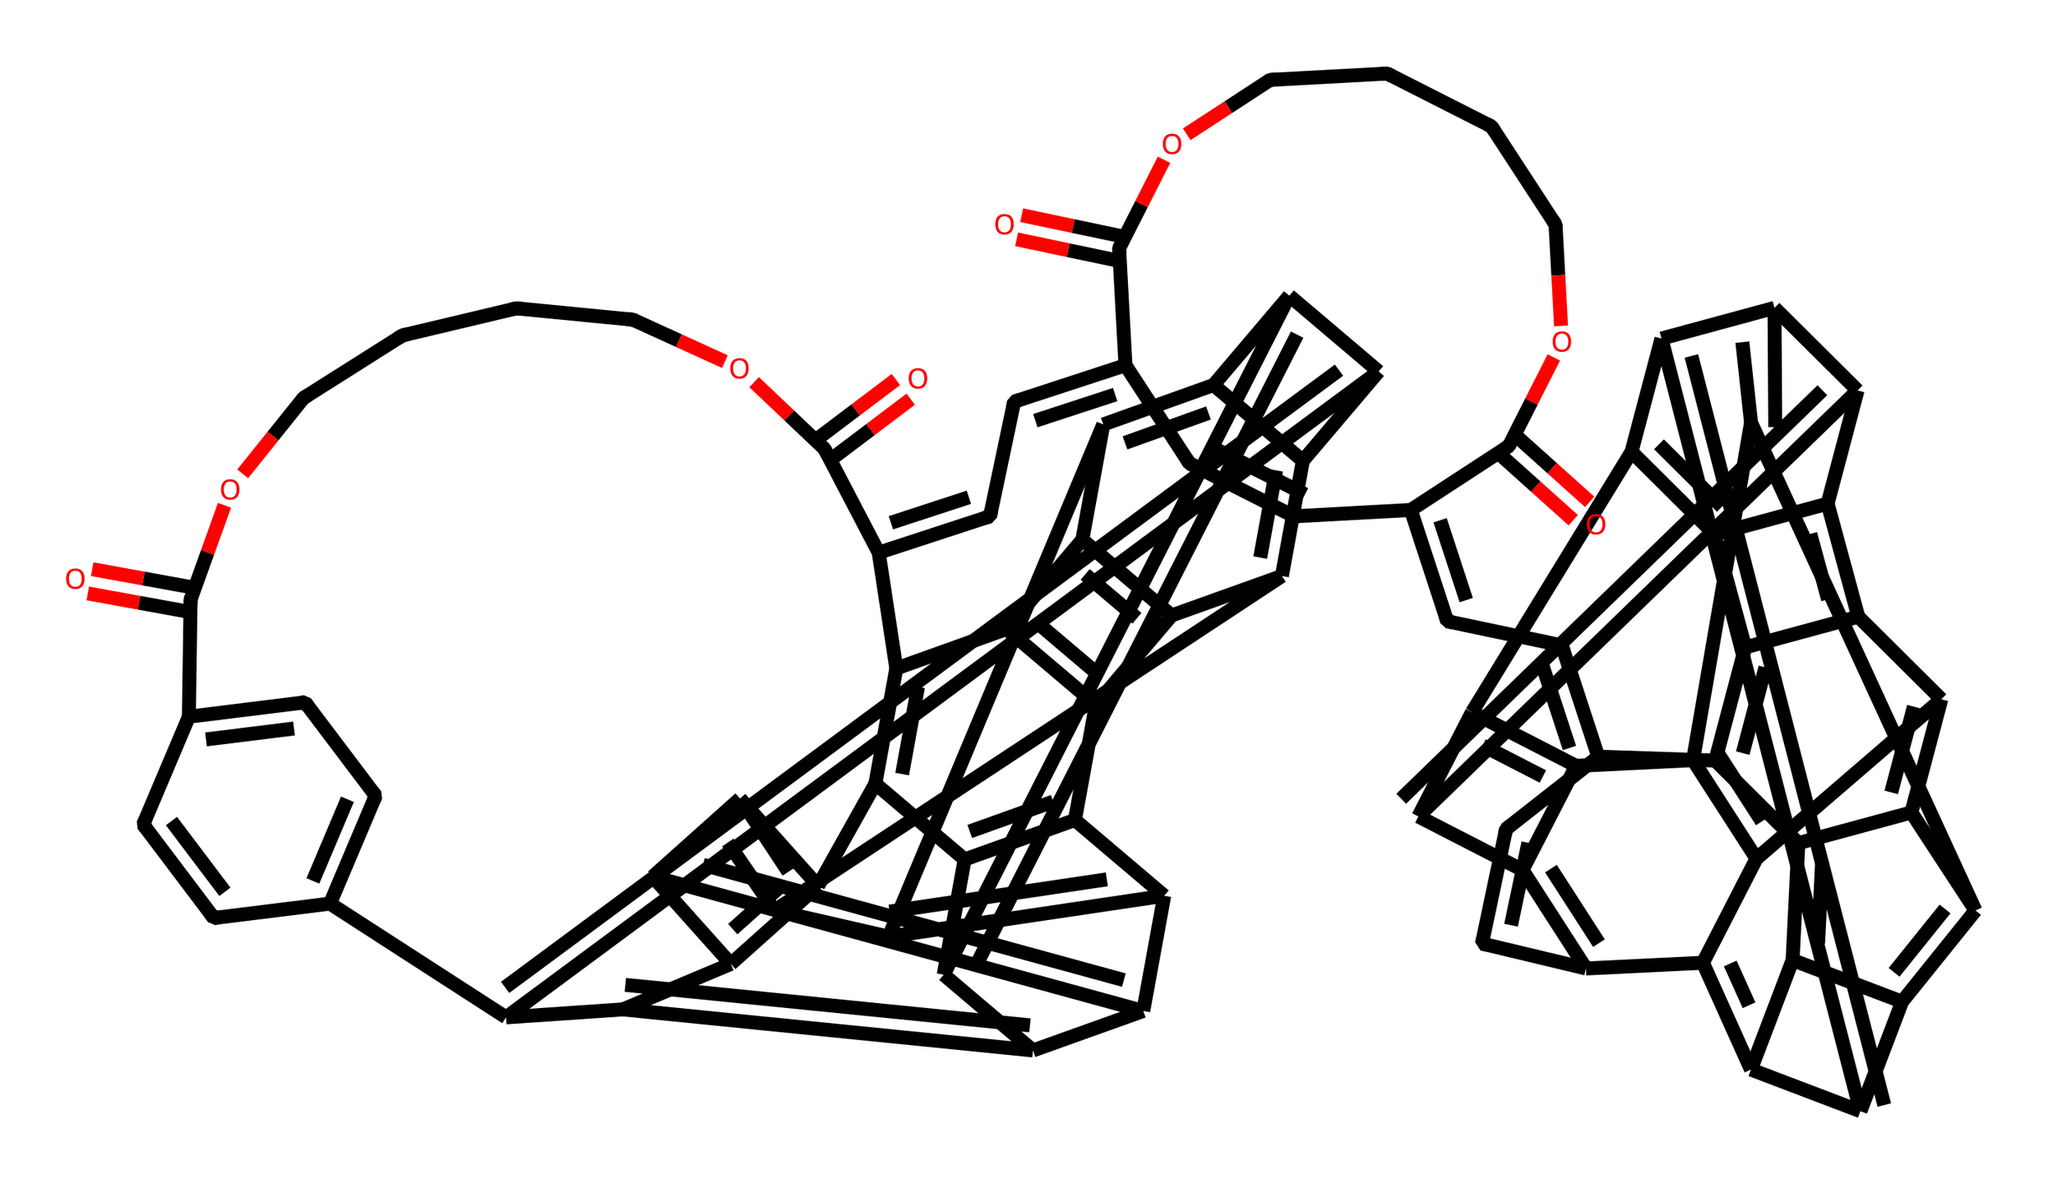What is the main functional group present in this chemical? The presence of "C(=O)O" indicates carboxyl groups, which are functional groups typically involved in the formation of esters and acids.
Answer: carboxyl How many rings are present in the structure of this fullerene derivative? By analyzing the SMILES representation, we can identify multiple fused aromatic rings. The structure reveals a complex arrangement of interconnected rings totalling 12 distinct fused rings.
Answer: twelve What is the primary purpose of incorporating fullerene in golf club shafts? Fullerenes are known for their exceptional strength and lightweight properties, which enhance the performance and durability of golf club shafts made from this material.
Answer: durability What type of polymeric structure is formed with the addition of fullerene? The integration of fullerenes into the polymer matrix leads to a composite structure, where strong intermolecular interactions are formed, making the material weather-resistant.
Answer: composite How many carbon atoms are represented in the chemical structure? By counting the carbon atoms in the SMILES string, it’s determined that there are 68 carbon atoms altogether in this complex structure.
Answer: sixty-eight What effect does the presence of ester linkages have on this composite material? The ester linkages, seen in the repeating units of the structure, enhance flexibility and contribute to the material's durability, making it more resilient to weather conditions.
Answer: flexibility What characteristic gives fullerene-polymer composites their resistance to environmental factors? The extensive network of interconnected carbon atoms in fullerene provides high mechanical strength, while the polymeric components add resistance to moisture and UV degradation.
Answer: mechanical strength 